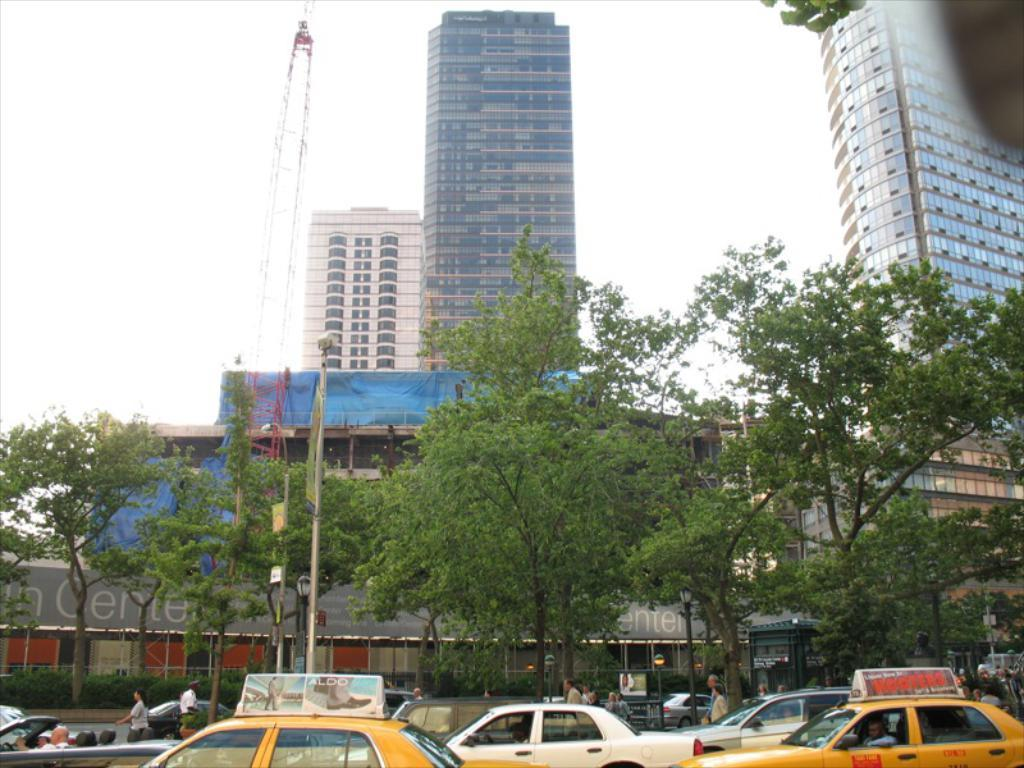<image>
Offer a succinct explanation of the picture presented. Buildings sitting behind some yellow taxis and the word CENTER in the back. 